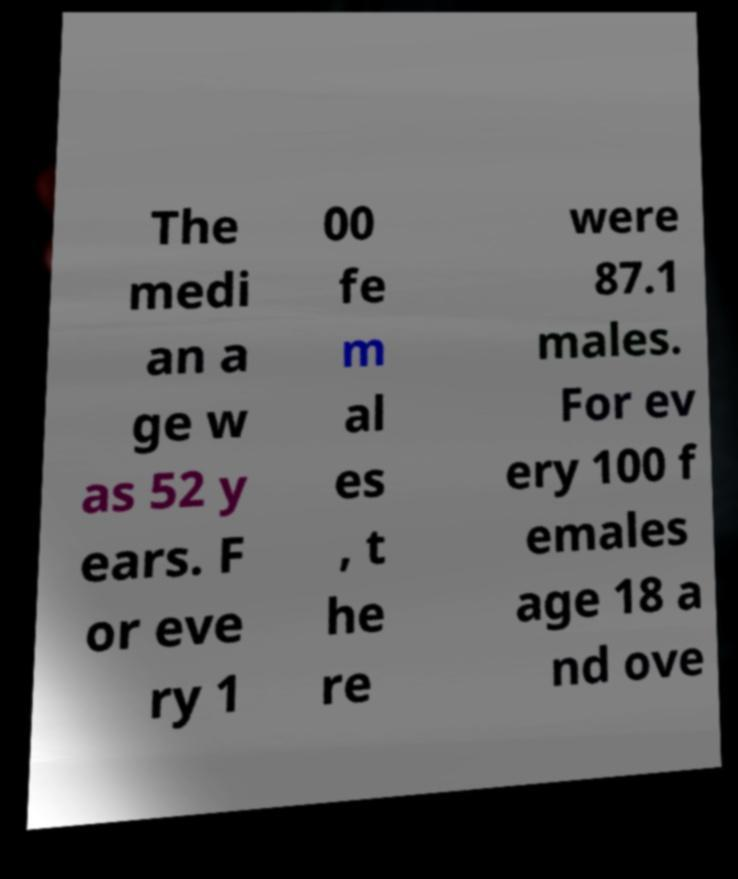What messages or text are displayed in this image? I need them in a readable, typed format. The medi an a ge w as 52 y ears. F or eve ry 1 00 fe m al es , t he re were 87.1 males. For ev ery 100 f emales age 18 a nd ove 